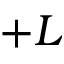Convert formula to latex. <formula><loc_0><loc_0><loc_500><loc_500>+ L</formula> 